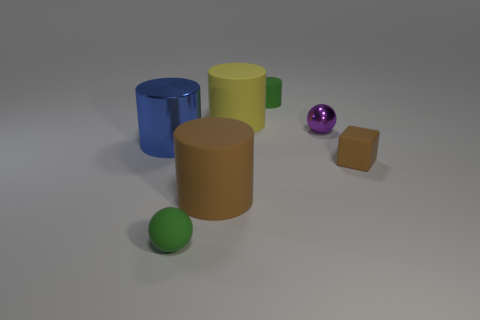There is another small thing that is the same shape as the purple thing; what is its material?
Your response must be concise. Rubber. There is a big blue shiny cylinder; are there any cylinders in front of it?
Make the answer very short. Yes. How many cyan things are there?
Offer a very short reply. 0. What number of spheres are on the left side of the small rubber thing behind the purple ball?
Your answer should be compact. 1. There is a rubber block; does it have the same color as the large matte cylinder on the left side of the yellow matte cylinder?
Offer a terse response. Yes. How many green things are the same shape as the tiny purple metal thing?
Make the answer very short. 1. What material is the sphere that is to the left of the yellow object?
Your response must be concise. Rubber. Does the tiny green matte thing that is in front of the matte cube have the same shape as the tiny purple object?
Your answer should be compact. Yes. Are there any other spheres that have the same size as the rubber sphere?
Give a very brief answer. Yes. Is the shape of the big blue metallic object the same as the green object that is in front of the tiny green matte cylinder?
Your answer should be very brief. No. 